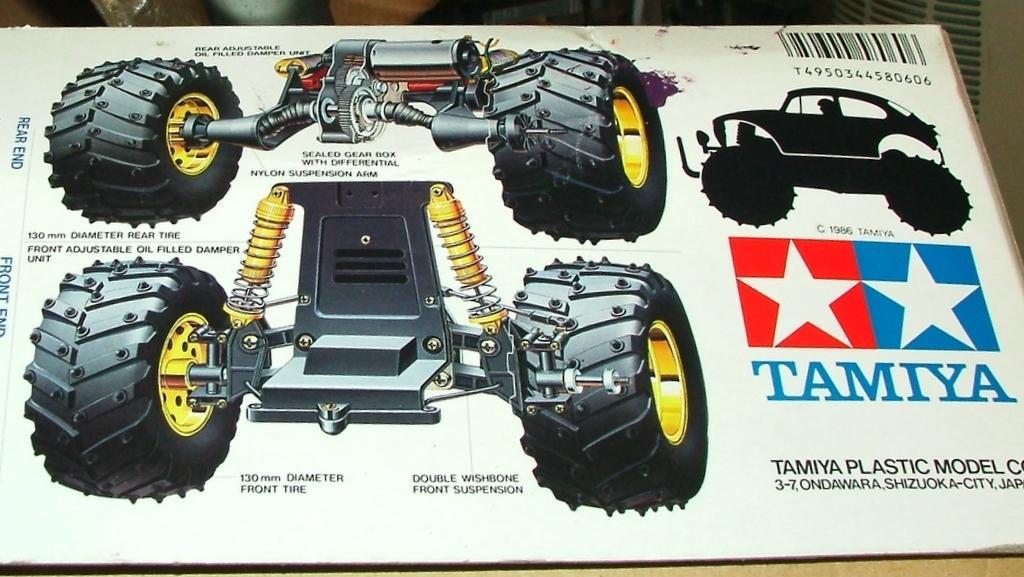In one or two sentences, can you explain what this image depicts? In the picture we can see a box on it, we can see a poster with some vehicle parts and wheels and a label TANYA written on it with two star symbols. 